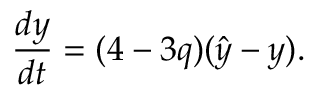Convert formula to latex. <formula><loc_0><loc_0><loc_500><loc_500>\frac { d y } { d t } = ( 4 - 3 q ) ( \hat { y } - y ) .</formula> 